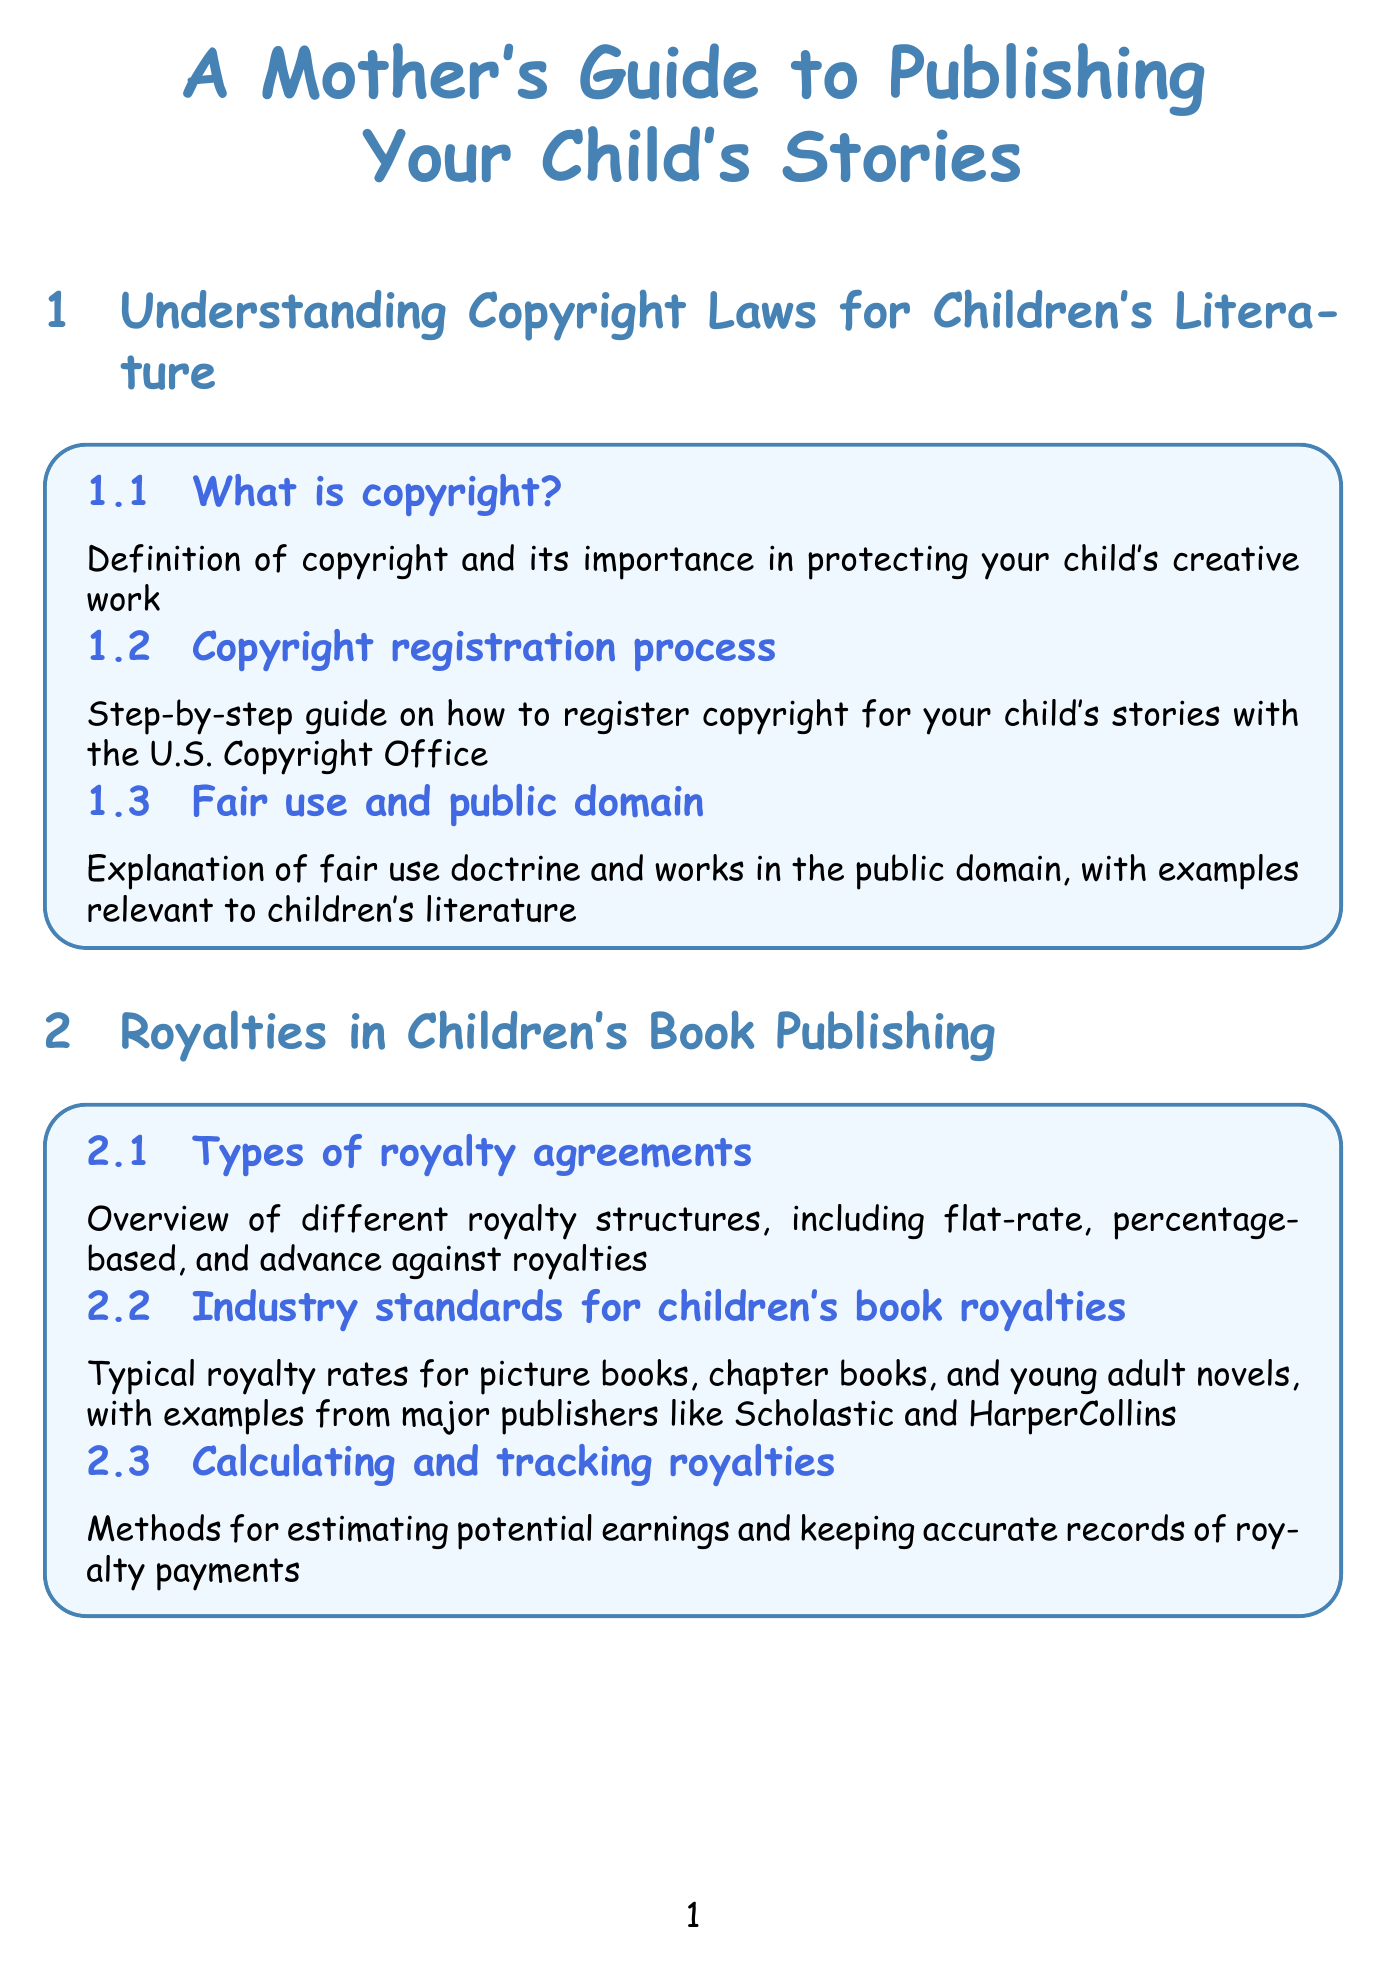What is copyright? The document defines copyright and explains its importance in protecting creative work, specifically focusing on children's literature.
Answer: Definition of copyright and its importance in protecting your child's creative work What are the types of royalty agreements? The manual provides an overview of the different royalty structures related to children's book publishing, such as flat-rate and percentage-based agreements.
Answer: Overview of different royalty structures, including flat-rate, percentage-based, and advance against royalties What are common legal safeguards for minors? This question refers to the section about protecting the interests of child authors, specifically legal considerations in the publishing industry.
Answer: Legal safeguards for minors in the publishing industry, including trust accounts and guardianship considerations What is a recommended platform for self-publishing? The document compares self-publishing platforms, emphasizing one of the options available for authors.
Answer: Amazon Kindle Direct Publishing What do literary agents help with? The manual discusses the role of literary agents in the publishing process and their benefits to authors.
Answer: Benefits of having a literary agent What is the typical royalty rate for picture books? This information pertains to the section that specifically addresses industry standards for children's book royalties.
Answer: Typical royalty rates for picture books, chapter books, and young adult novels, with examples from major publishers like Scholastic and HarperCollins What type of account helps with saving for the future? The document covers financial management, including options for managing a child's earnings.
Answer: Custodial accounts What are the pros of traditional publishing? The manual outlines the traditional publishing process and compares it to self-publishing options, hinting at advantages of traditional methods.
Answer: Overview of submission guidelines, query letters, and the acquisition process for major children's book publishers What should a book launch event include? The document provides ideas for organizing successful promotional events for children's books, addressing launch activities specifically.
Answer: Ideas for organizing successful book launch parties and readings at local bookstores 